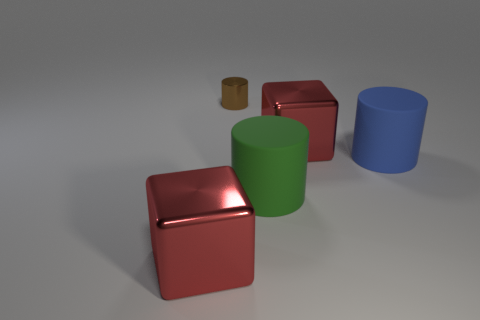Subtract all small brown metal cylinders. How many cylinders are left? 2 Add 2 big cubes. How many objects exist? 7 Subtract all blocks. How many objects are left? 3 Subtract all green cylinders. How many cylinders are left? 2 Subtract all brown shiny cylinders. Subtract all metal cylinders. How many objects are left? 3 Add 3 big red cubes. How many big red cubes are left? 5 Add 5 large gray matte cubes. How many large gray matte cubes exist? 5 Subtract 0 purple spheres. How many objects are left? 5 Subtract all purple cylinders. Subtract all brown spheres. How many cylinders are left? 3 